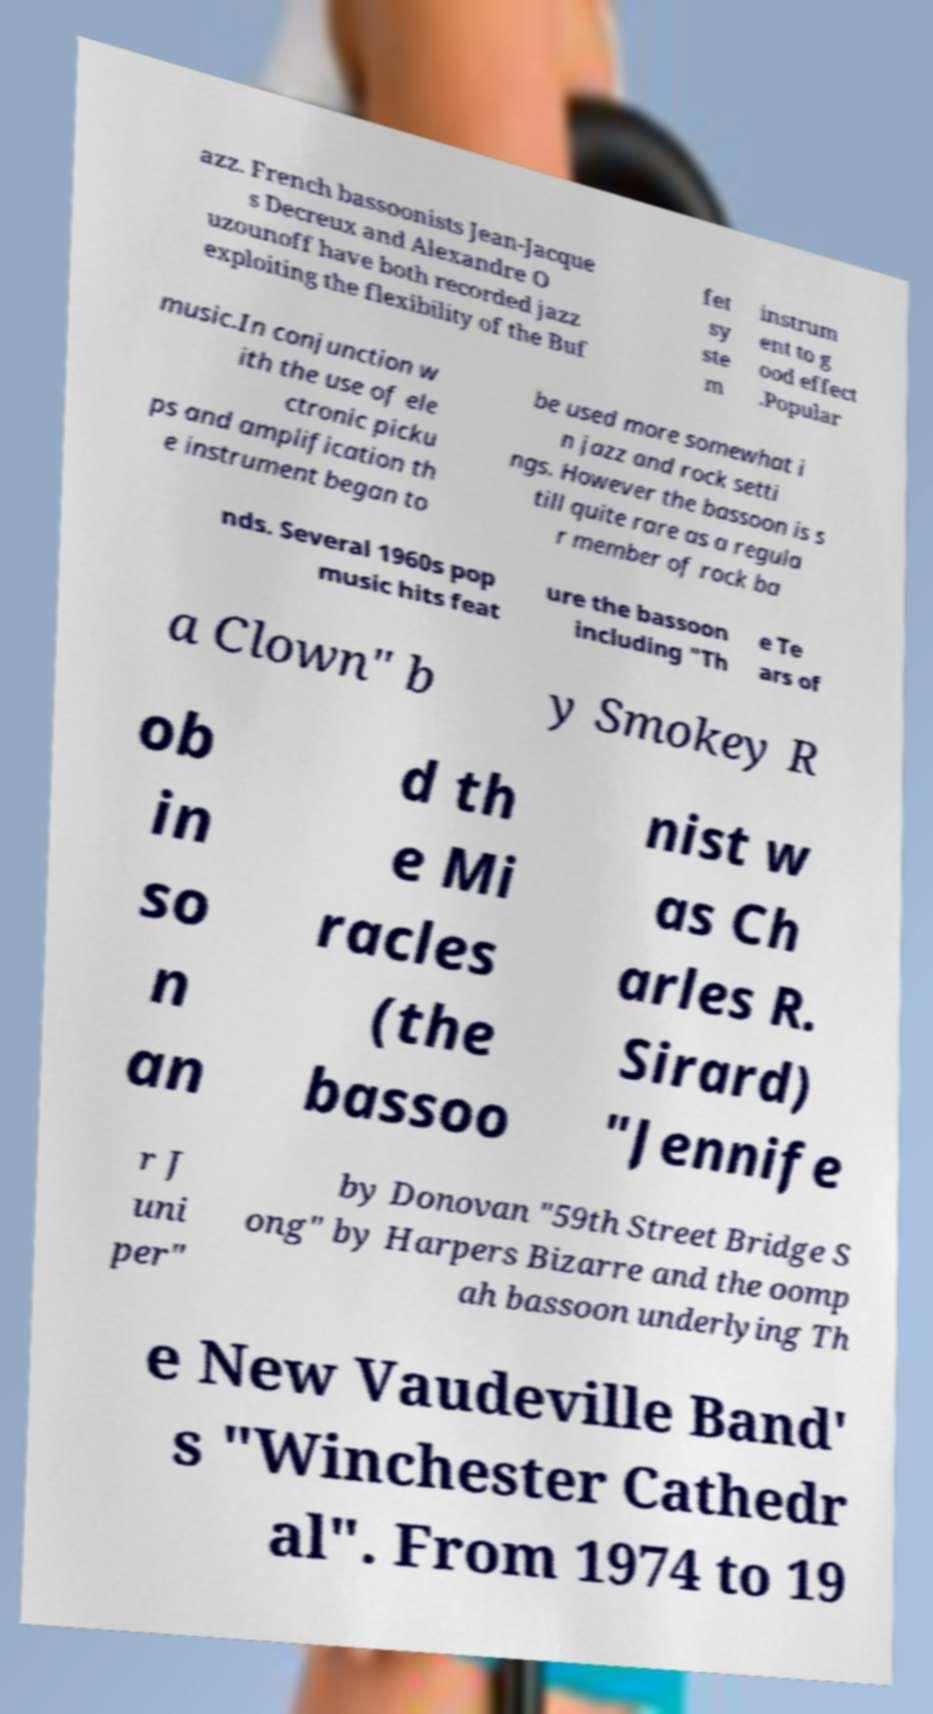For documentation purposes, I need the text within this image transcribed. Could you provide that? Certainly! The text within the image reads: 'Jazz. French bassoonists Jean-Jacques Decreux and Alexandre Ouzounoff have both recorded jazz exploiting the flexibility of the Buffet system instrument to good effect. Popular music. In conjunction with the use of electronic pickups and amplification the instrument began to be used more somewhat in jazz and rock settings. However, the bassoon is still quite rare as a regular member of rock bands. Several 1960s pop music hits feature the bassoon including "The Tears of a Clown" by Smokey Robinson and the Miracles (the bassoonist was Charles R. Sirard), "Jennifer Juniper" by Donovan, "59th Street Bridge Song" by Harpers Bizarre, and the oompah bassoon underlying The New Vaudeville Band's "Winchester Cathedral". From 1974 to 19'. 